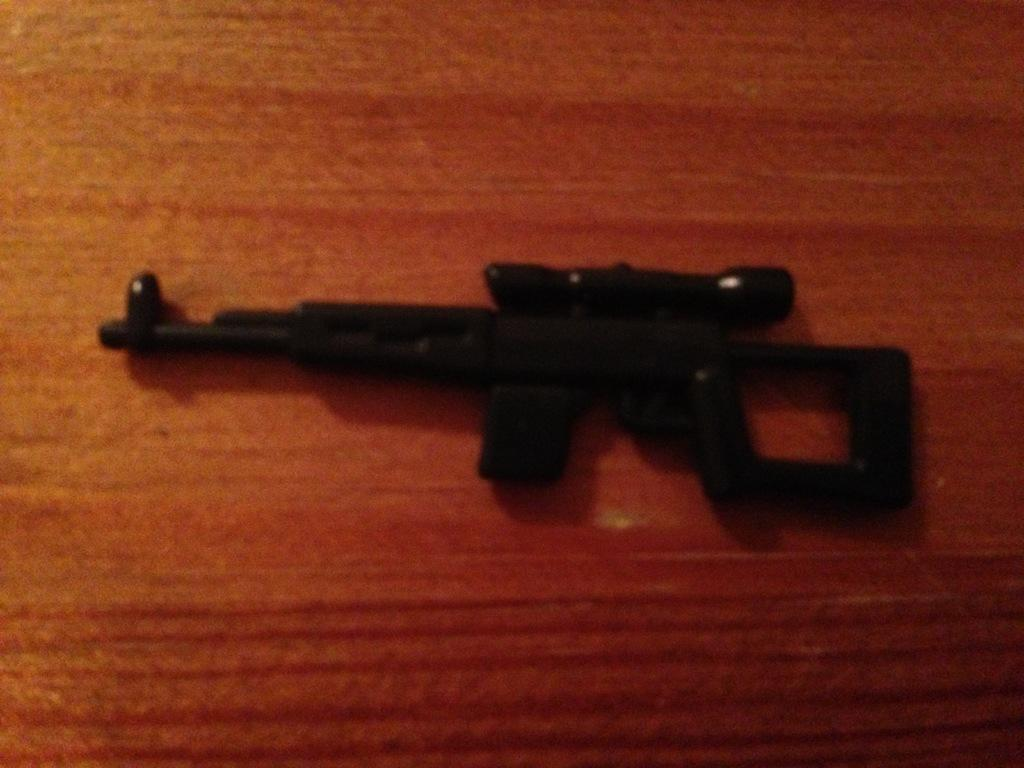What object is on the floor in the image? There is a gun on the floor in the image. What songs is the actor singing while holding the vase in the image? There is no actor, songs, or vase present in the image; it only features a gun on the floor. 